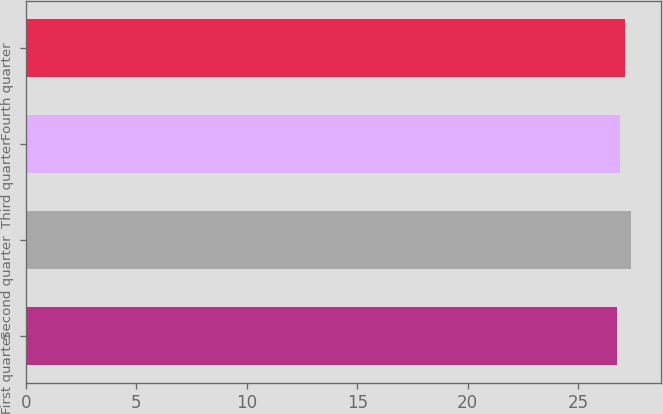<chart> <loc_0><loc_0><loc_500><loc_500><bar_chart><fcel>First quarter<fcel>Second quarter<fcel>Third quarter<fcel>Fourth quarter<nl><fcel>26.77<fcel>27.38<fcel>26.9<fcel>27.14<nl></chart> 